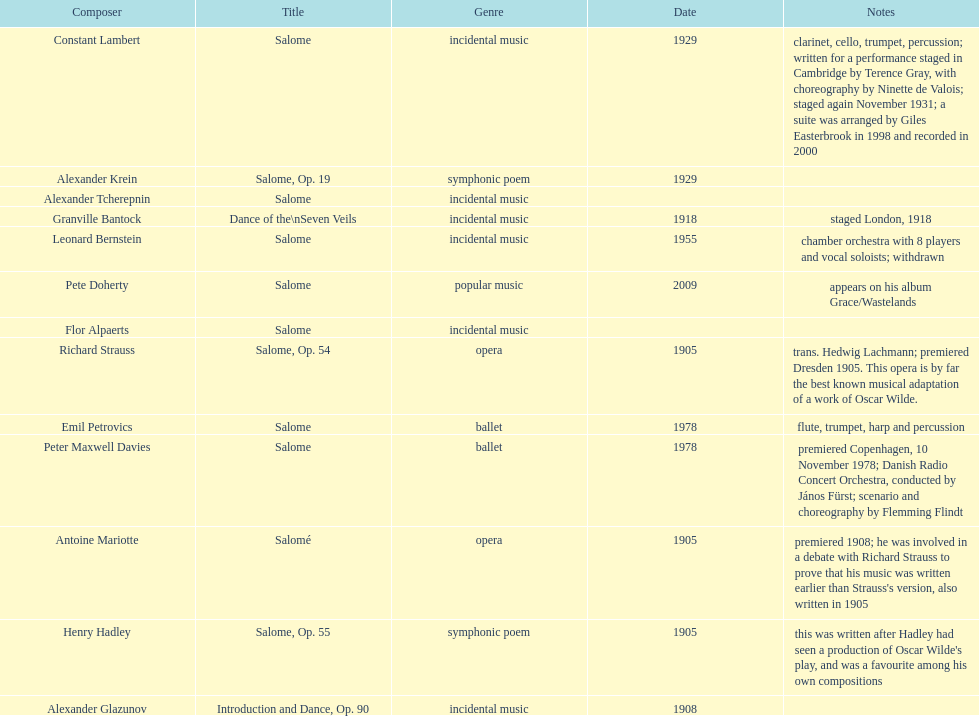How many are symphonic poems? 2. 